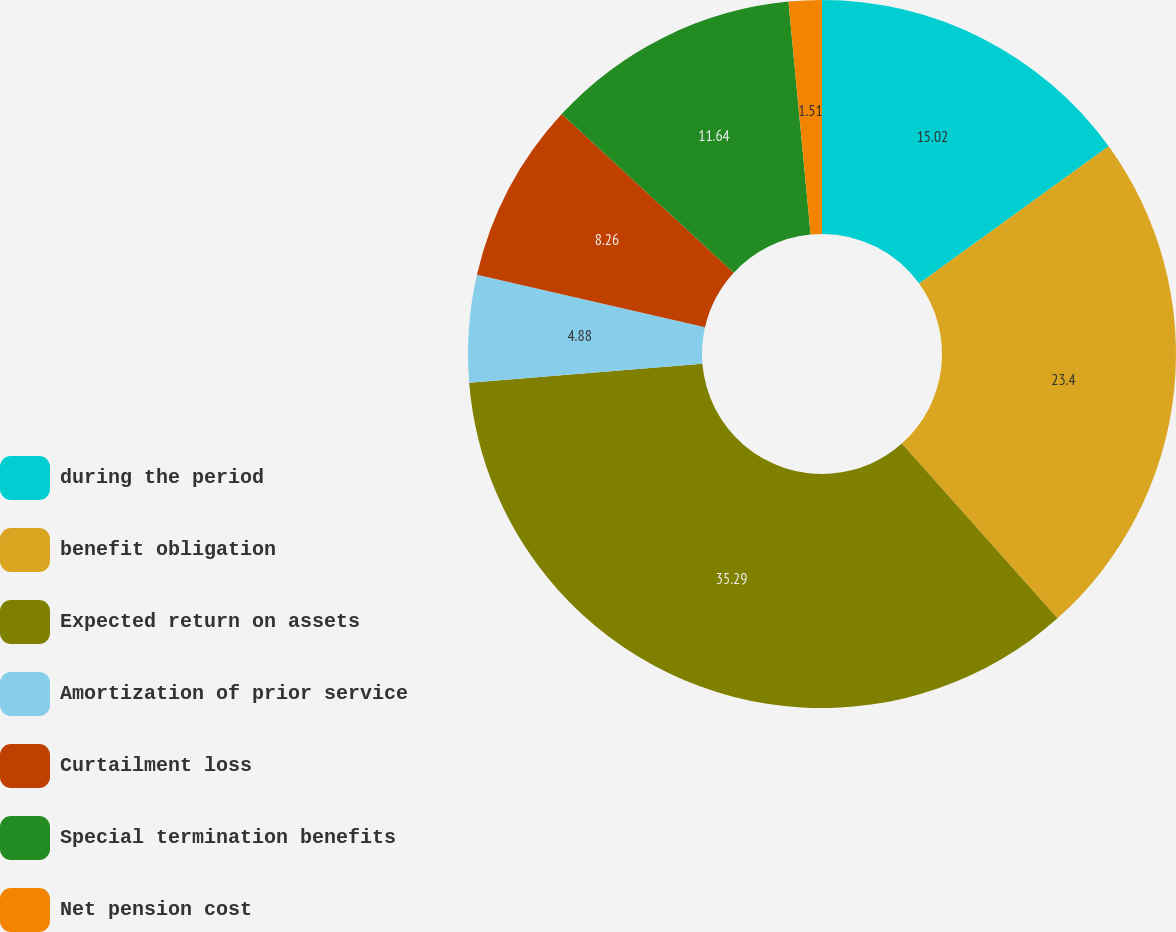Convert chart. <chart><loc_0><loc_0><loc_500><loc_500><pie_chart><fcel>during the period<fcel>benefit obligation<fcel>Expected return on assets<fcel>Amortization of prior service<fcel>Curtailment loss<fcel>Special termination benefits<fcel>Net pension cost<nl><fcel>15.02%<fcel>23.4%<fcel>35.29%<fcel>4.88%<fcel>8.26%<fcel>11.64%<fcel>1.51%<nl></chart> 